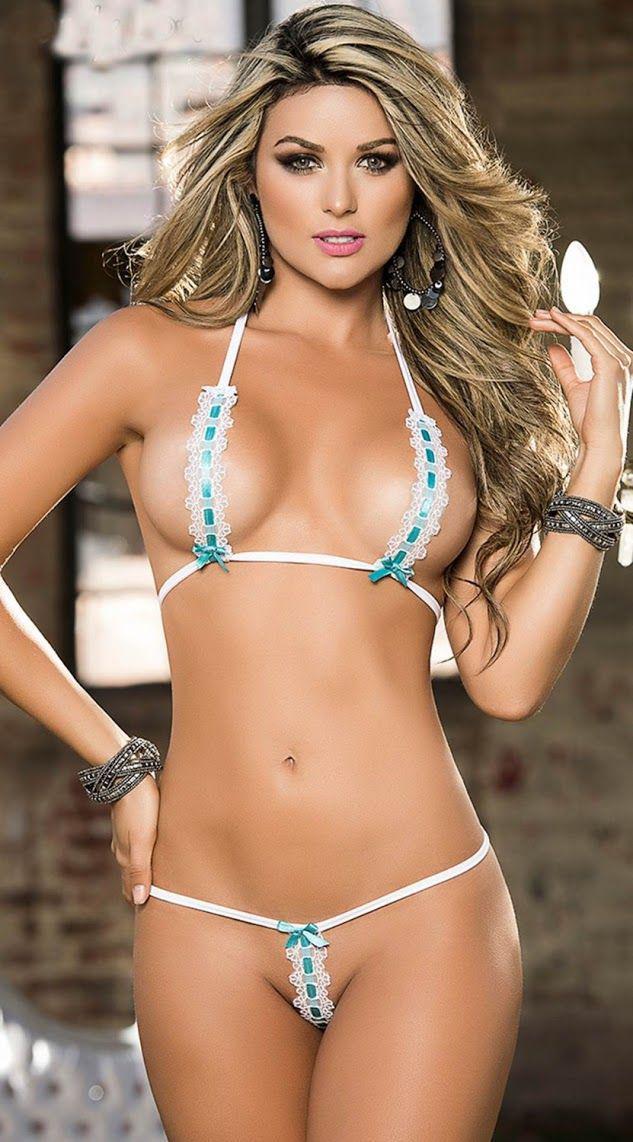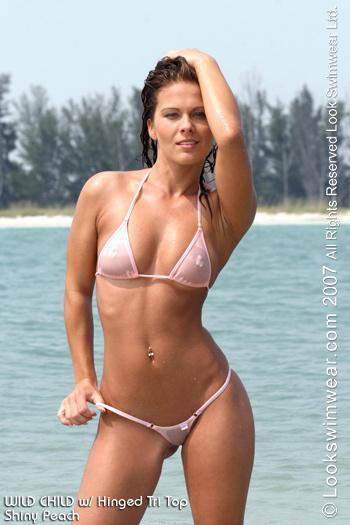The first image is the image on the left, the second image is the image on the right. For the images displayed, is the sentence "The bikini belonging to the woman on the left is only one color: white." factually correct? Answer yes or no. No. The first image is the image on the left, the second image is the image on the right. Examine the images to the left and right. Is the description "Each image shows a bikini model standing with the hand on the right lifted to her hair, but only one of the models has her other arm bent at the elbow with a hand above her hip." accurate? Answer yes or no. Yes. 